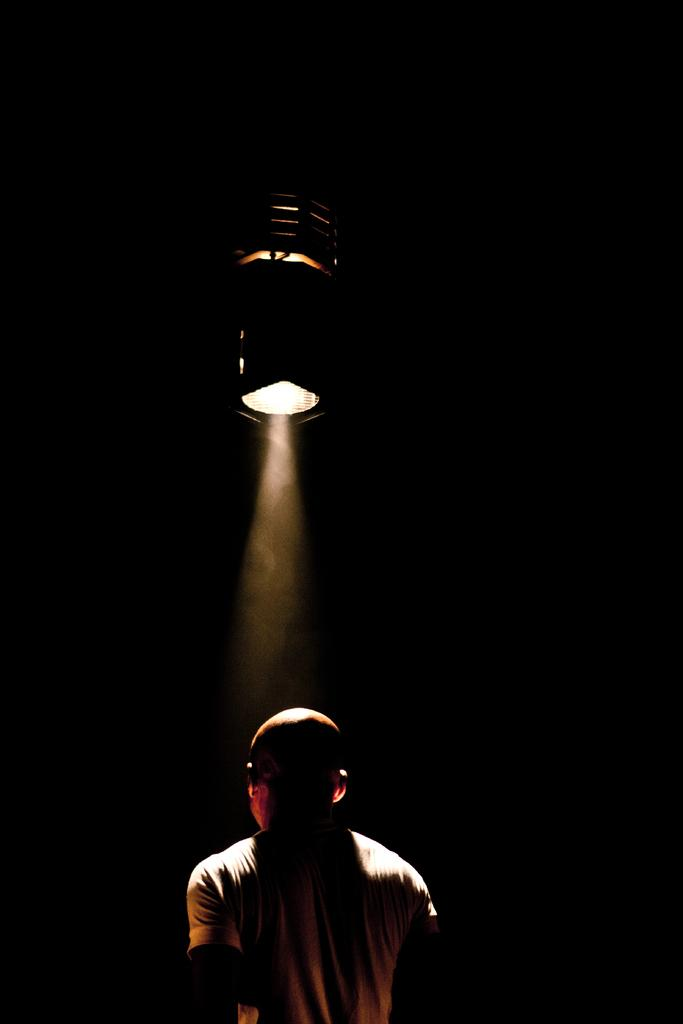What is the main subject of the image? There is a person standing in the image. What can be observed about the background of the image? The background of the image is dark. Despite the dark background, is there any light visible? Yes, there is light visible in the background of the image. What type of scent can be detected in the image? There is no information about any scent in the image, as it focuses on the visual aspects of the scene. 